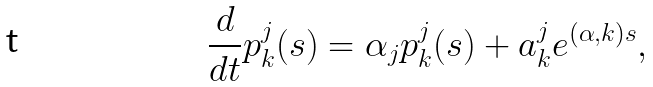Convert formula to latex. <formula><loc_0><loc_0><loc_500><loc_500>\frac { d } { d t } p ^ { j } _ { k } ( s ) = \alpha _ { j } p _ { k } ^ { j } ( s ) + a _ { k } ^ { j } e ^ { ( \alpha , k ) s } ,</formula> 